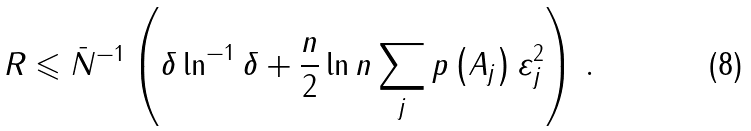<formula> <loc_0><loc_0><loc_500><loc_500>R \leqslant \bar { N } ^ { - 1 } \left ( { \delta \ln ^ { - 1 } \delta + \frac { n } { 2 } \ln n \sum _ { j } p \left ( { A _ { j } } \right ) \varepsilon _ { j } ^ { 2 } } \right ) \, .</formula> 